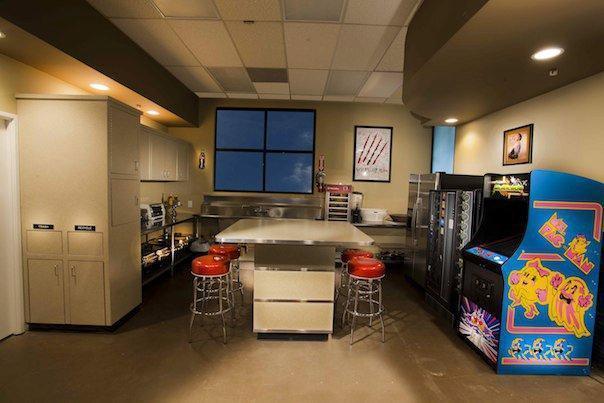How many refrigerators can you see?
Give a very brief answer. 2. How many chairs are in the picture?
Give a very brief answer. 2. 